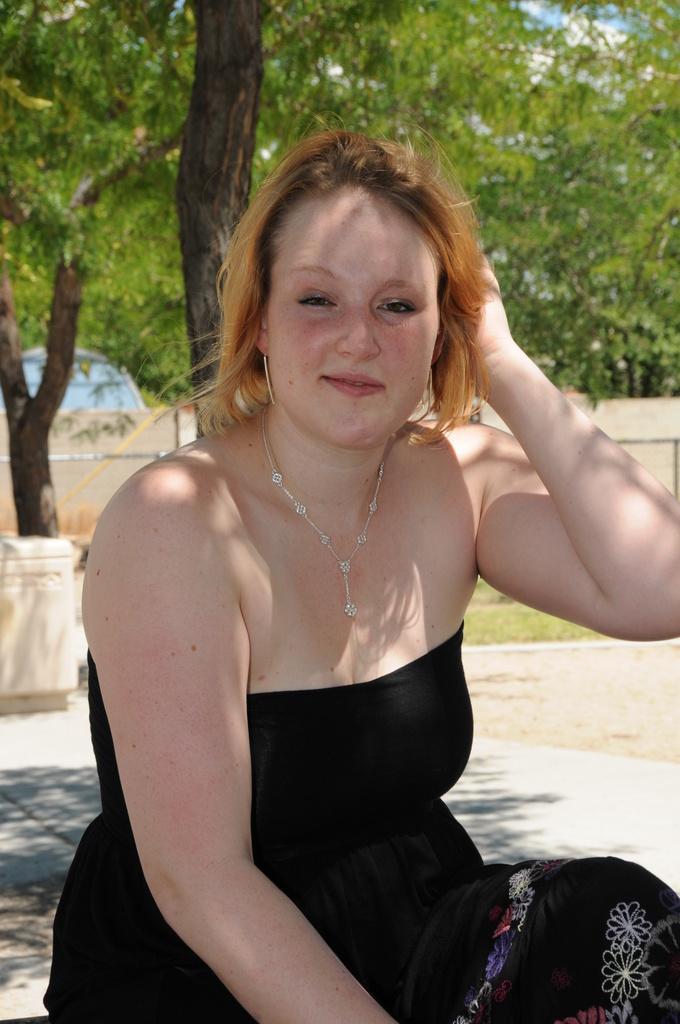Can you describe this image briefly? In this image we can see there is the person sitting on the ground. At the back there are trees, grass, vehicle, wall and box. 